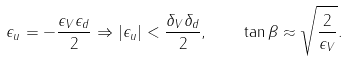<formula> <loc_0><loc_0><loc_500><loc_500>\epsilon _ { u } = - \frac { \epsilon _ { V } \epsilon _ { d } } { 2 } \Rightarrow | \epsilon _ { u } | < \frac { \delta _ { V } \delta _ { d } } { 2 } , \quad \tan \beta \approx \sqrt { \frac { 2 } { \epsilon _ { V } } } .</formula> 